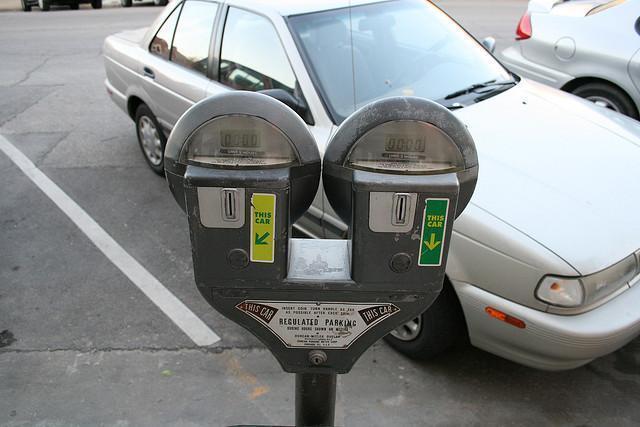How many parking meters?
Give a very brief answer. 2. How many parking meters are there?
Give a very brief answer. 2. How many cars are there?
Give a very brief answer. 2. 